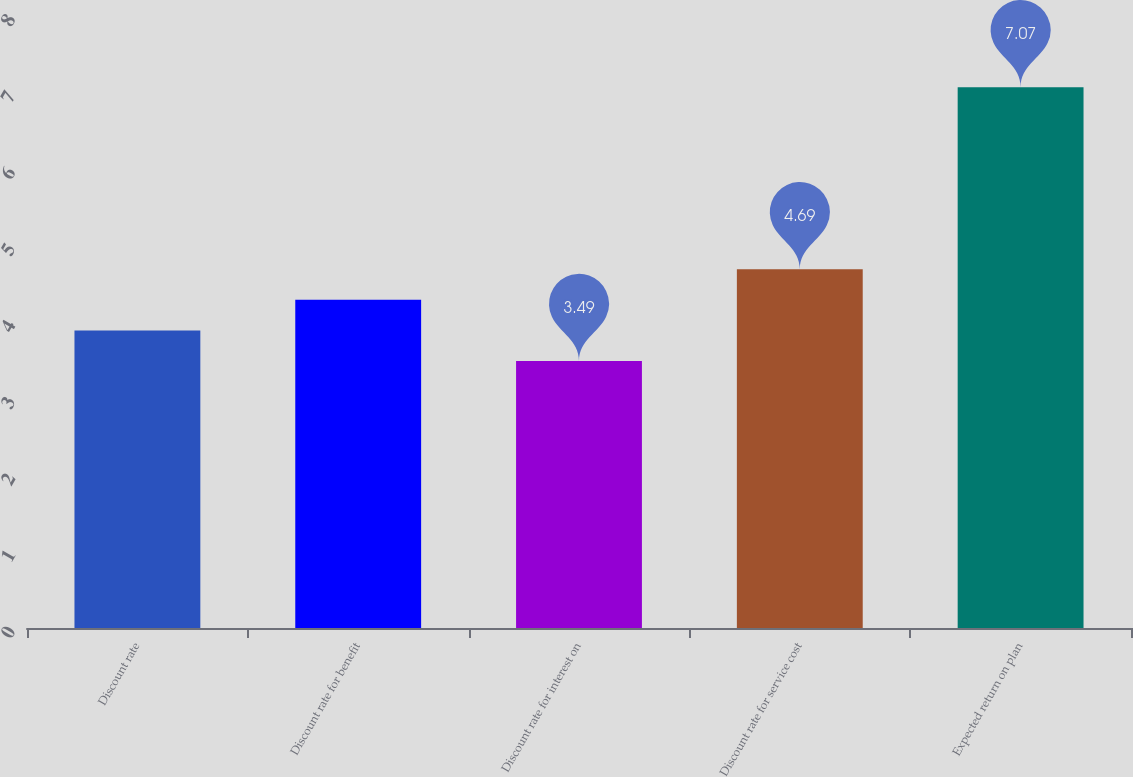Convert chart to OTSL. <chart><loc_0><loc_0><loc_500><loc_500><bar_chart><fcel>Discount rate<fcel>Discount rate for benefit<fcel>Discount rate for interest on<fcel>Discount rate for service cost<fcel>Expected return on plan<nl><fcel>3.89<fcel>4.29<fcel>3.49<fcel>4.69<fcel>7.07<nl></chart> 